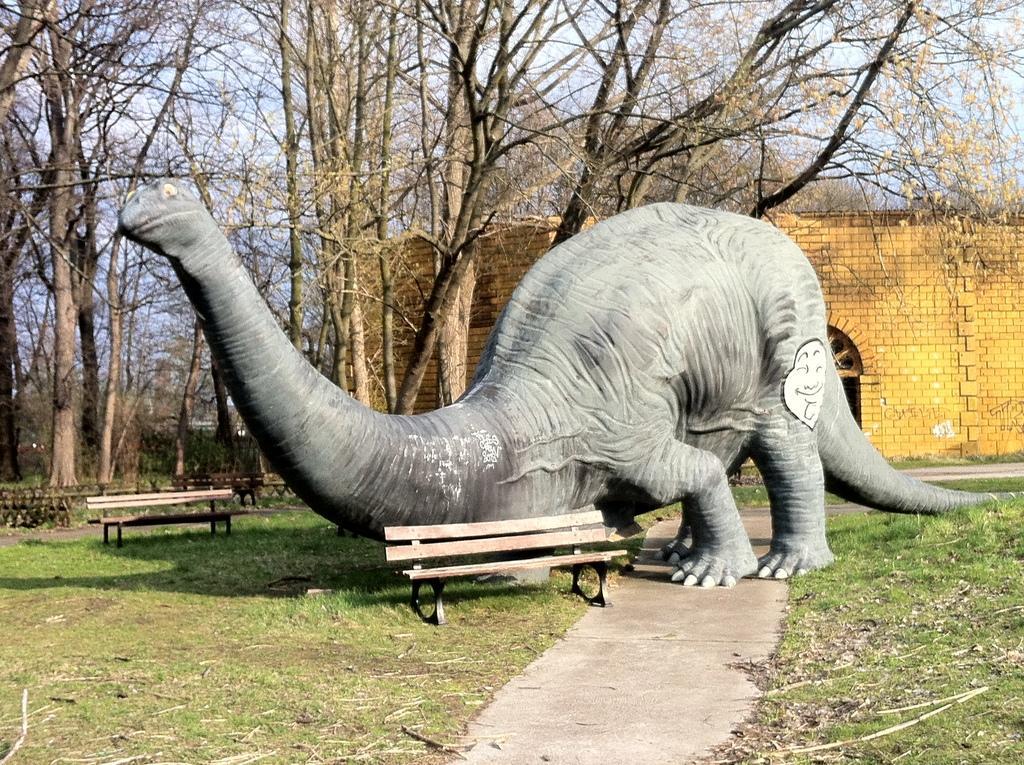Describe this image in one or two sentences. In the picture I can see a statue of a dinosaur, benches, a building, the grass and trees. In the background I can see the sky. 